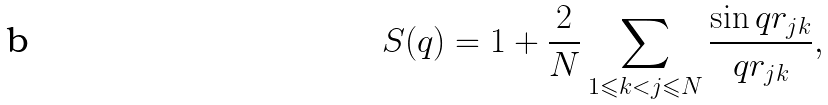<formula> <loc_0><loc_0><loc_500><loc_500>S ( q ) = 1 + \frac { 2 } { N } \sum _ { 1 \leqslant k < j \leqslant N } \frac { \sin q r _ { j k } } { q r _ { j k } } ,</formula> 